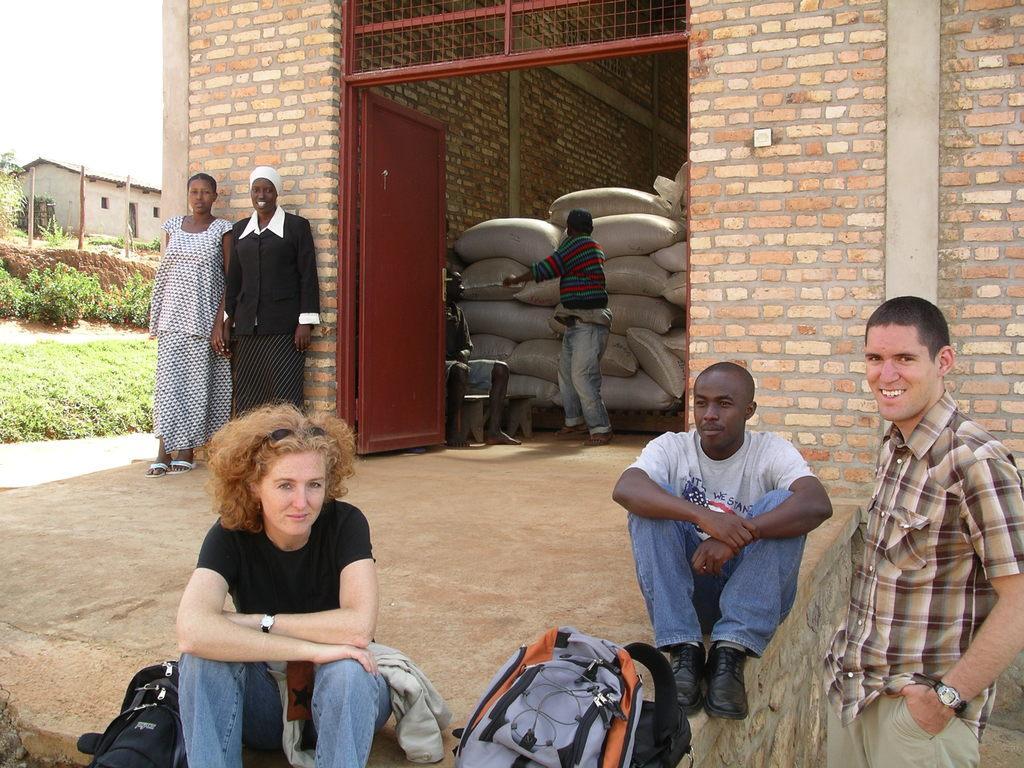Describe this image in one or two sentences. In the center of the image we can see person standing at the door. At the bottom of the image we can see persons and bags. On the left side of the image we can see persons standing to the wall. In the background we can see sky, house, trees, plants and grass. 